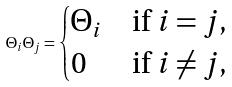<formula> <loc_0><loc_0><loc_500><loc_500>\Theta _ { i } \Theta _ { j } = \begin{cases} \Theta _ { i } & \text {if } i = j , \\ 0 & \text {if } i \neq j , \end{cases}</formula> 